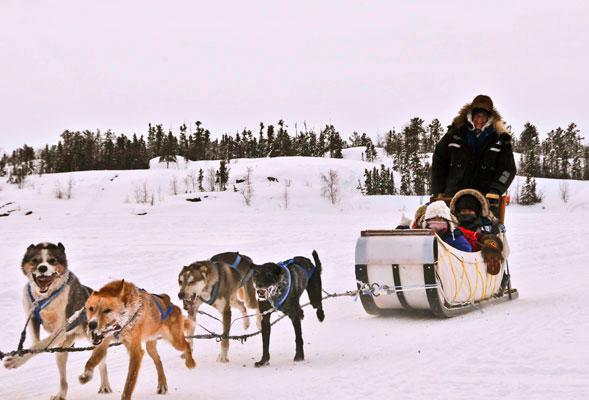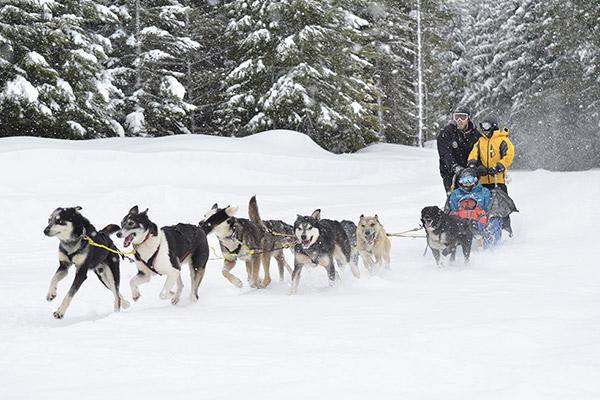The first image is the image on the left, the second image is the image on the right. Analyze the images presented: Is the assertion "At least one of the images features six or less dogs pulling a sled." valid? Answer yes or no. Yes. The first image is the image on the left, the second image is the image on the right. Considering the images on both sides, is "Right image shows a sled dog team with a mountain range behind them." valid? Answer yes or no. No. 